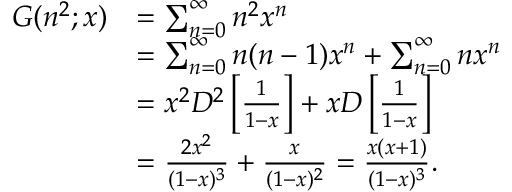<formula> <loc_0><loc_0><loc_500><loc_500>{ \begin{array} { r l } { G ( n ^ { 2 } ; x ) } & { = \sum _ { n = 0 } ^ { \infty } n ^ { 2 } x ^ { n } } \\ & { = \sum _ { n = 0 } ^ { \infty } n ( n - 1 ) x ^ { n } + \sum _ { n = 0 } ^ { \infty } n x ^ { n } } \\ & { = x ^ { 2 } D ^ { 2 } \left [ { \frac { 1 } { 1 - x } } \right ] + x D \left [ { \frac { 1 } { 1 - x } } \right ] } \\ & { = { \frac { 2 x ^ { 2 } } { ( 1 - x ) ^ { 3 } } } + { \frac { x } { ( 1 - x ) ^ { 2 } } } = { \frac { x ( x + 1 ) } { ( 1 - x ) ^ { 3 } } } . } \end{array} }</formula> 